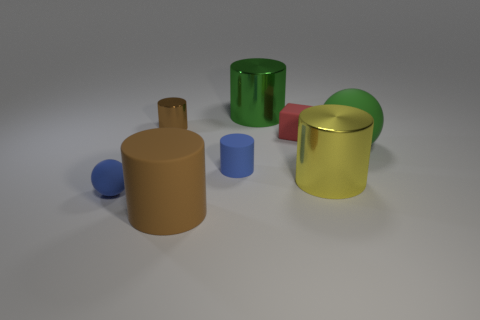How does the lighting in this image affect the colors and mood? The image has a soft and diffuse lighting condition, which gives a calm and serene mood to it. The colors appear true to life and the shadows are gentle, creating a realistic depiction of the objects. 